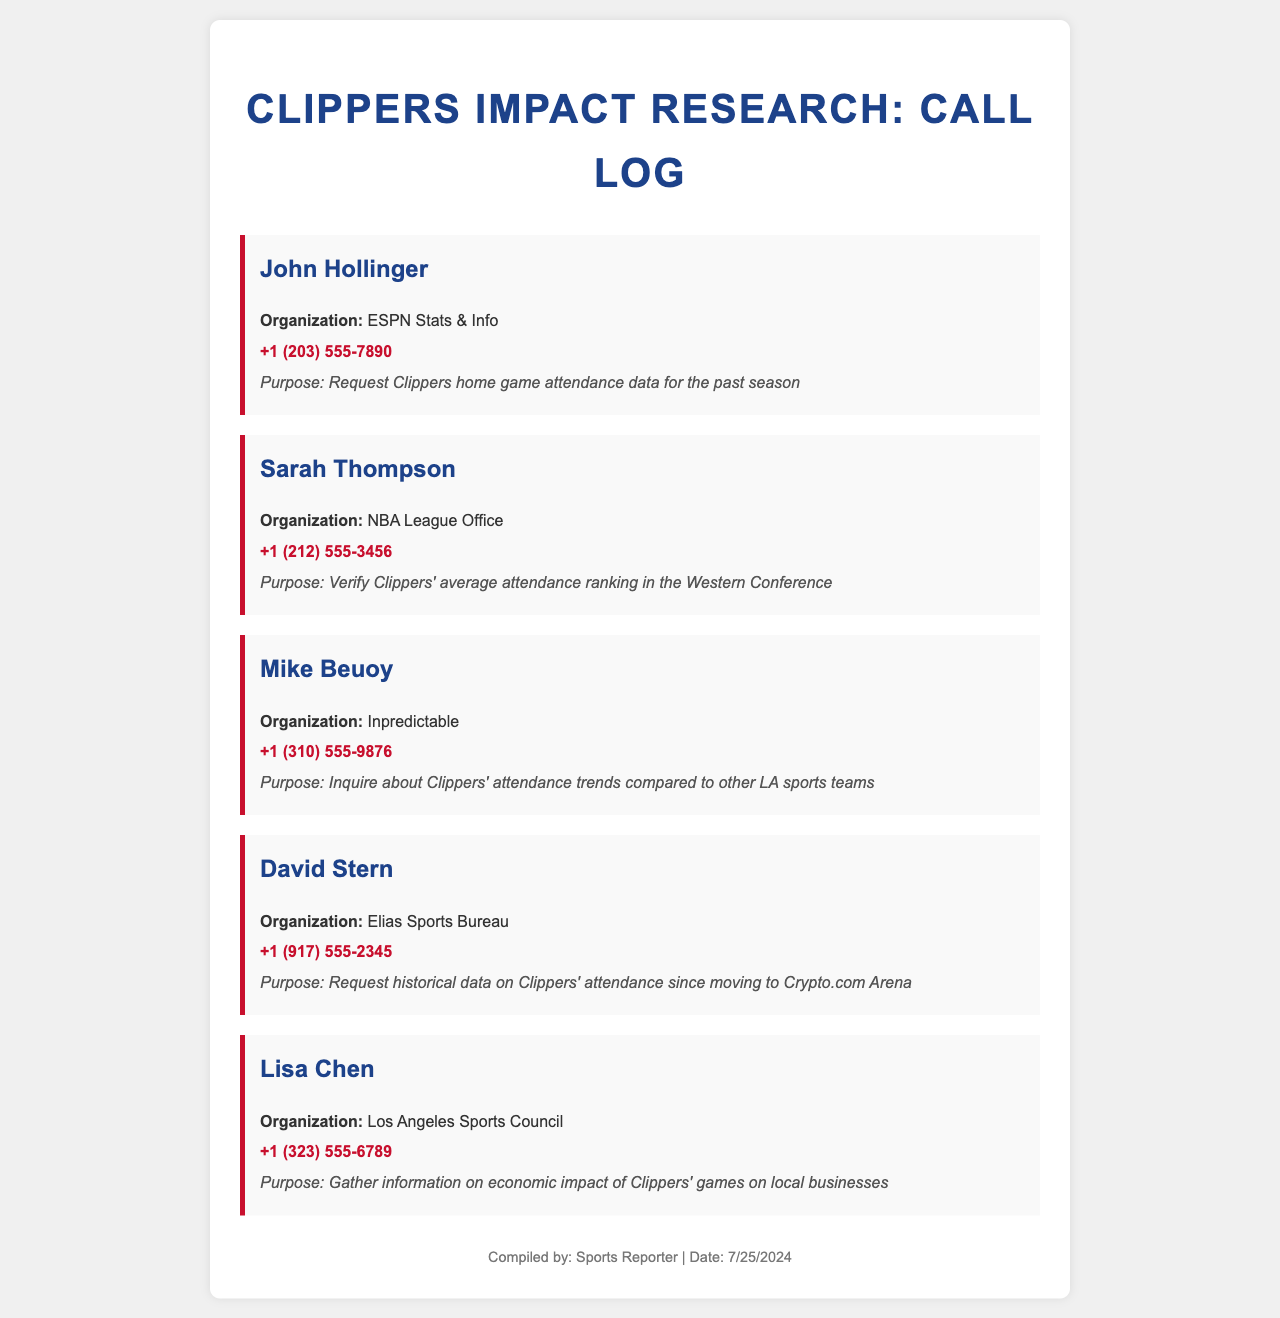What is the name of the organization associated with John Hollinger? John Hollinger is associated with ESPN Stats & Info, as stated in the document.
Answer: ESPN Stats & Info What is the phone number for Sarah Thompson? The document lists the phone number for Sarah Thompson as +1 (212) 555-3456.
Answer: +1 (212) 555-3456 Who was inquiring about attendance trends compared to other LA sports teams? The inquiry regarding attendance trends compared to other LA sports teams was made by Mike Beuoy.
Answer: Mike Beuoy What is the purpose of Lisa Chen's call? Lisa Chen's call aimed to gather information on the economic impact of Clippers' games on local businesses.
Answer: Gather information on economic impact of Clippers' games on local businesses How many individuals are listed in the call log? The document includes a total of five individuals in the call log mentioned.
Answer: Five What type of data did David Stern request? David Stern requested historical data on Clippers' attendance since moving to Crypto.com Arena.
Answer: Historical data on Clippers' attendance Which organization did Mike Beuoy represent? Mike Beuoy represented Inpredictable, as noted in the document.
Answer: Inpredictable What was Sarah Thompson verifying? Sarah Thompson was verifying Clippers' average attendance ranking in the Western Conference.
Answer: Clippers' average attendance ranking in the Western Conference 